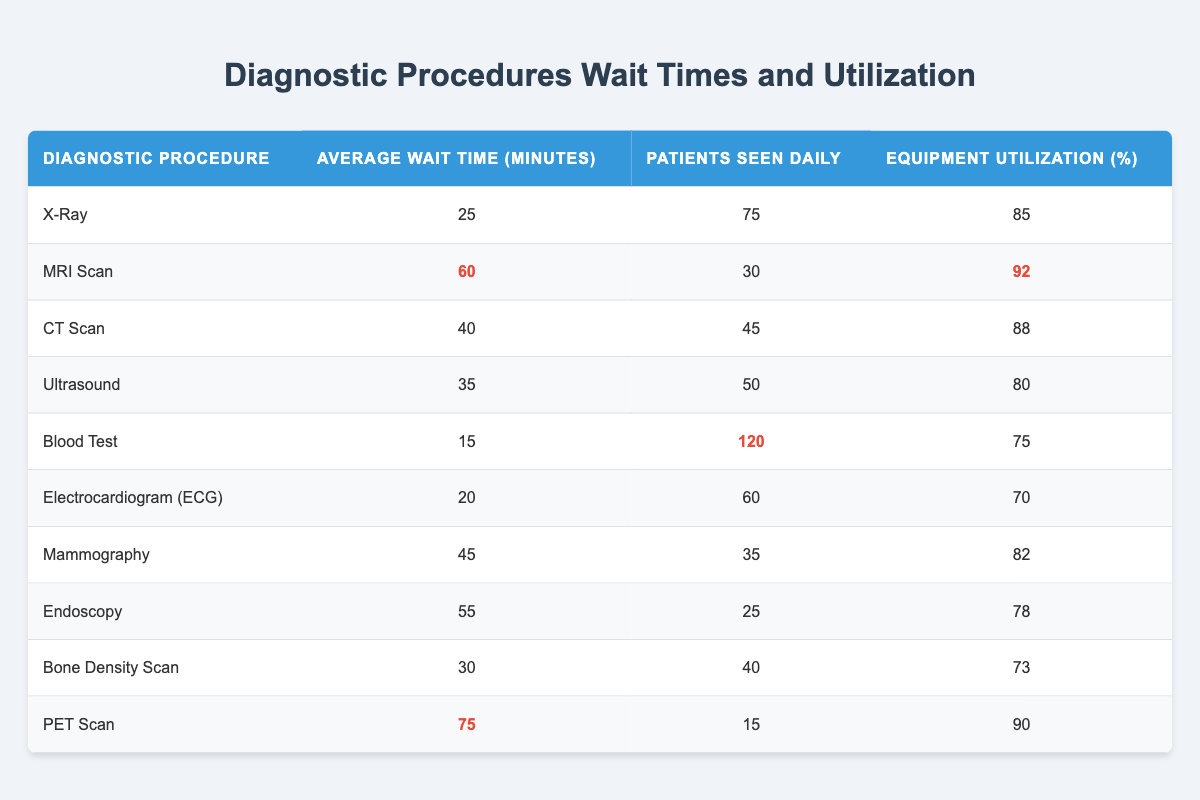What is the average wait time for an MRI Scan? According to the table, the average wait time for an MRI Scan is listed in the second column next to its name. The value directly from the table is 60 minutes.
Answer: 60 minutes Which diagnostic procedure has the highest equipment utilization percentage? The equipment utilization percentage for all procedures is found in the fourth column. By comparing these values, it is clear that the MRI Scan has the highest utilization at 92%.
Answer: MRI Scan How many patients are seen daily for a Blood Test? The number of patients seen daily for a Blood Test is found in the third column next to its name. The table lists it as 120 patients.
Answer: 120 patients What is the difference in average wait time between the PET Scan and the X-Ray? The average wait time for a PET Scan is 75 minutes and for an X-Ray, it is 25 minutes according to the table. The difference is calculated as 75 - 25 = 50 minutes.
Answer: 50 minutes Is the average wait time for a CT Scan more than 40 minutes? Referring to the table, the average wait time for a CT Scan is listed as 40 minutes, which indicates that it is not more than 40. Hence the answer is no.
Answer: No What is the average number of patients seen daily across all procedures? To find the average number of patients seen daily, we sum up the patients seen for each procedure: 75 + 30 + 45 + 50 + 120 + 60 + 35 + 25 + 40 + 15 = 455. Dividing this total by 10 (the number of procedures) gives us an average of 45.5 patients.
Answer: 45.5 patients Is the average wait time for Ultrasound less than the average wait time for Electrocardiogram? Looking at the table, the average wait time for Ultrasound is 35 minutes while for ECG it's 20 minutes. Since 35 is greater than 20, the answer is no.
Answer: No Which procedure has the lowest average wait time and what is that time? The average wait time for all procedures was checked, and the lowest is found beside the Blood Test, which is 15 minutes.
Answer: Blood Test, 15 minutes What is the combined average wait time for the X-Ray and Bone Density Scan? To find the combined average wait time, we add the wait times from the table: 25 (X-Ray) + 30 (Bone Density Scan) = 55 minutes, then divide by 2 (the number of procedures) to find the average gives us 27.5 minutes.
Answer: 27.5 minutes 